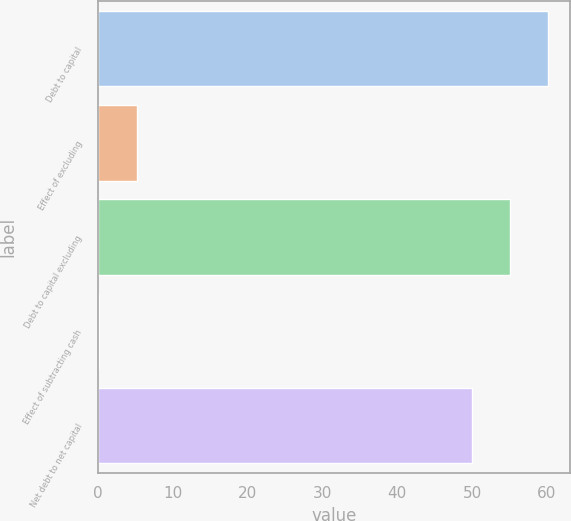Convert chart. <chart><loc_0><loc_0><loc_500><loc_500><bar_chart><fcel>Debt to capital<fcel>Effect of excluding<fcel>Debt to capital excluding<fcel>Effect of subtracting cash<fcel>Net debt to net capital<nl><fcel>60.12<fcel>5.26<fcel>55.06<fcel>0.2<fcel>50<nl></chart> 